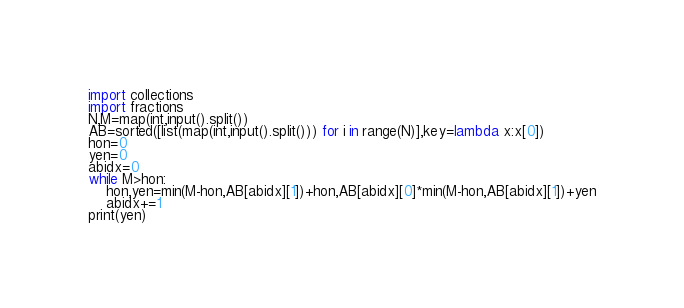<code> <loc_0><loc_0><loc_500><loc_500><_Python_>import collections
import fractions
N,M=map(int,input().split())
AB=sorted([list(map(int,input().split())) for i in range(N)],key=lambda x:x[0])
hon=0
yen=0
abidx=0
while M>hon:
    hon,yen=min(M-hon,AB[abidx][1])+hon,AB[abidx][0]*min(M-hon,AB[abidx][1])+yen
    abidx+=1
print(yen)
</code> 